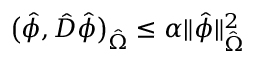Convert formula to latex. <formula><loc_0><loc_0><loc_500><loc_500>\left ( \hat { \phi } , \hat { D } \hat { \phi } \right ) _ { \hat { \Omega } } \leq \alpha \| \hat { \phi } \| _ { \hat { \Omega } } ^ { 2 }</formula> 